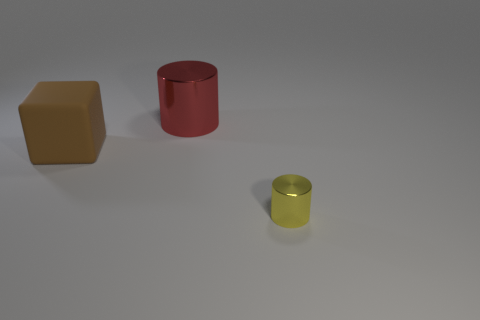Are there any other things that have the same size as the yellow metallic cylinder?
Your answer should be compact. No. What is the material of the cylinder in front of the cylinder behind the brown matte block?
Offer a very short reply. Metal. Does the big matte object have the same shape as the big metallic object?
Keep it short and to the point. No. What is the color of the metallic cylinder that is the same size as the matte cube?
Your answer should be very brief. Red. Is there a small yellow metal cylinder?
Ensure brevity in your answer.  Yes. Do the cylinder that is behind the tiny yellow object and the small yellow cylinder have the same material?
Your answer should be very brief. Yes. What number of metal cylinders are the same size as the brown thing?
Ensure brevity in your answer.  1. Are there an equal number of large brown rubber things that are on the right side of the tiny cylinder and small gray metallic things?
Provide a short and direct response. Yes. How many large things are both behind the brown object and in front of the red shiny cylinder?
Provide a short and direct response. 0. There is a yellow object that is made of the same material as the red thing; what is its size?
Your answer should be very brief. Small. 